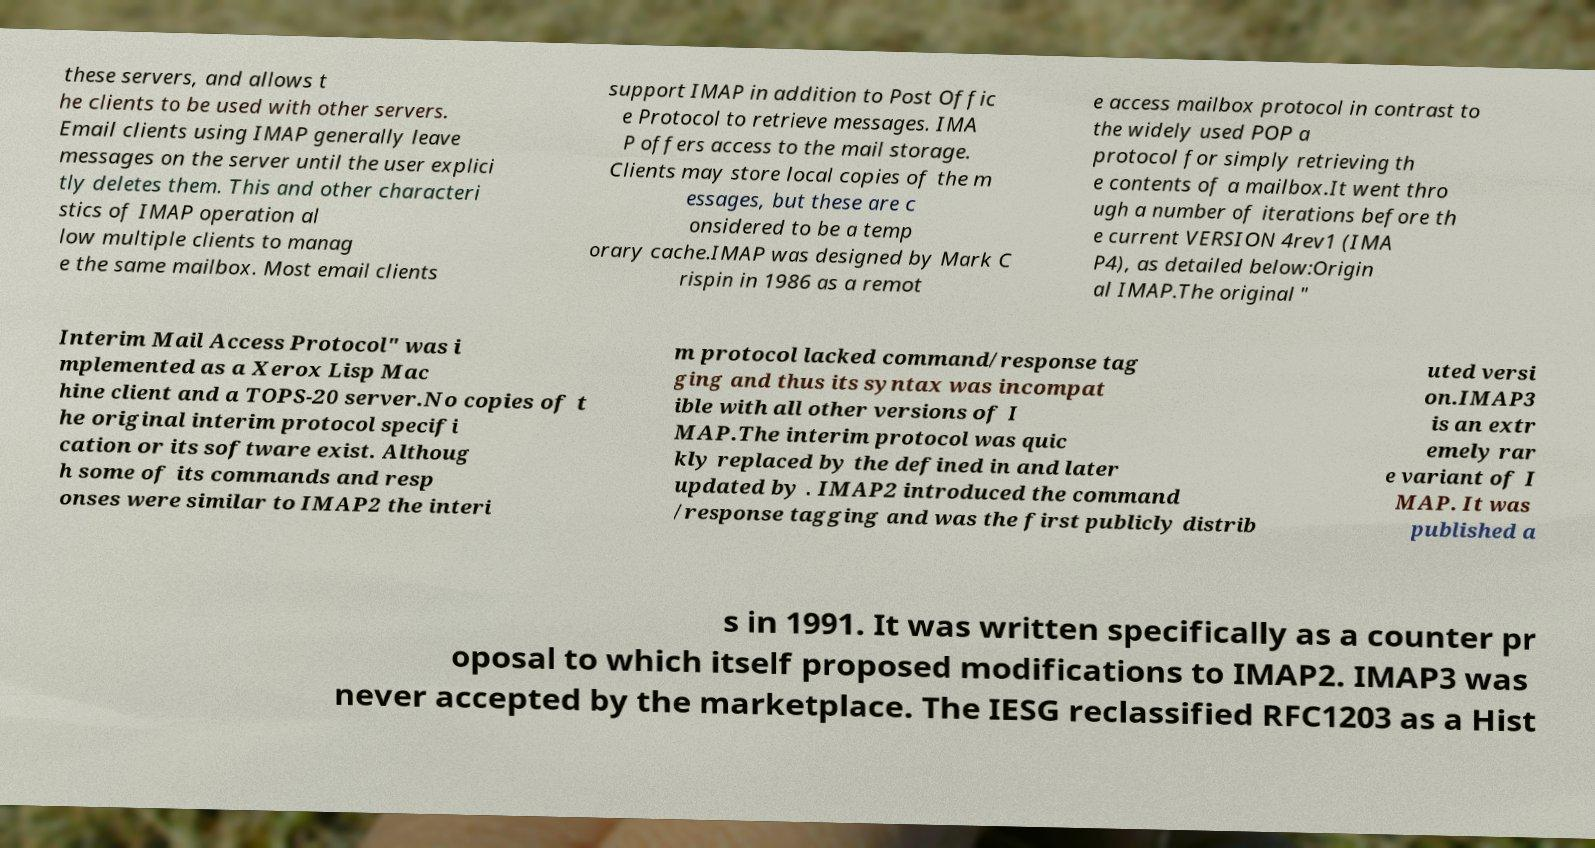Could you assist in decoding the text presented in this image and type it out clearly? these servers, and allows t he clients to be used with other servers. Email clients using IMAP generally leave messages on the server until the user explici tly deletes them. This and other characteri stics of IMAP operation al low multiple clients to manag e the same mailbox. Most email clients support IMAP in addition to Post Offic e Protocol to retrieve messages. IMA P offers access to the mail storage. Clients may store local copies of the m essages, but these are c onsidered to be a temp orary cache.IMAP was designed by Mark C rispin in 1986 as a remot e access mailbox protocol in contrast to the widely used POP a protocol for simply retrieving th e contents of a mailbox.It went thro ugh a number of iterations before th e current VERSION 4rev1 (IMA P4), as detailed below:Origin al IMAP.The original " Interim Mail Access Protocol" was i mplemented as a Xerox Lisp Mac hine client and a TOPS-20 server.No copies of t he original interim protocol specifi cation or its software exist. Althoug h some of its commands and resp onses were similar to IMAP2 the interi m protocol lacked command/response tag ging and thus its syntax was incompat ible with all other versions of I MAP.The interim protocol was quic kly replaced by the defined in and later updated by . IMAP2 introduced the command /response tagging and was the first publicly distrib uted versi on.IMAP3 is an extr emely rar e variant of I MAP. It was published a s in 1991. It was written specifically as a counter pr oposal to which itself proposed modifications to IMAP2. IMAP3 was never accepted by the marketplace. The IESG reclassified RFC1203 as a Hist 